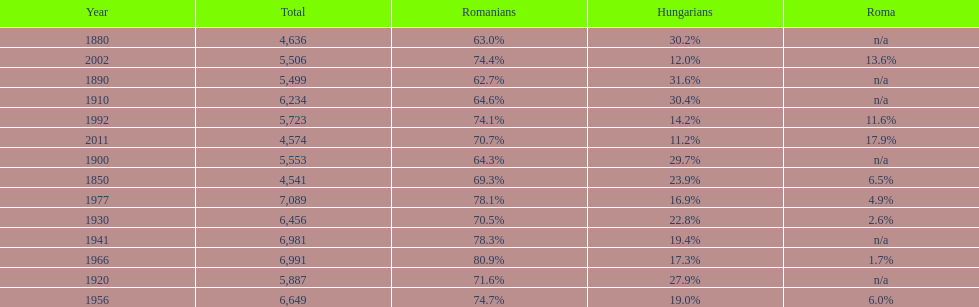1% romanian population precede? 1977. 